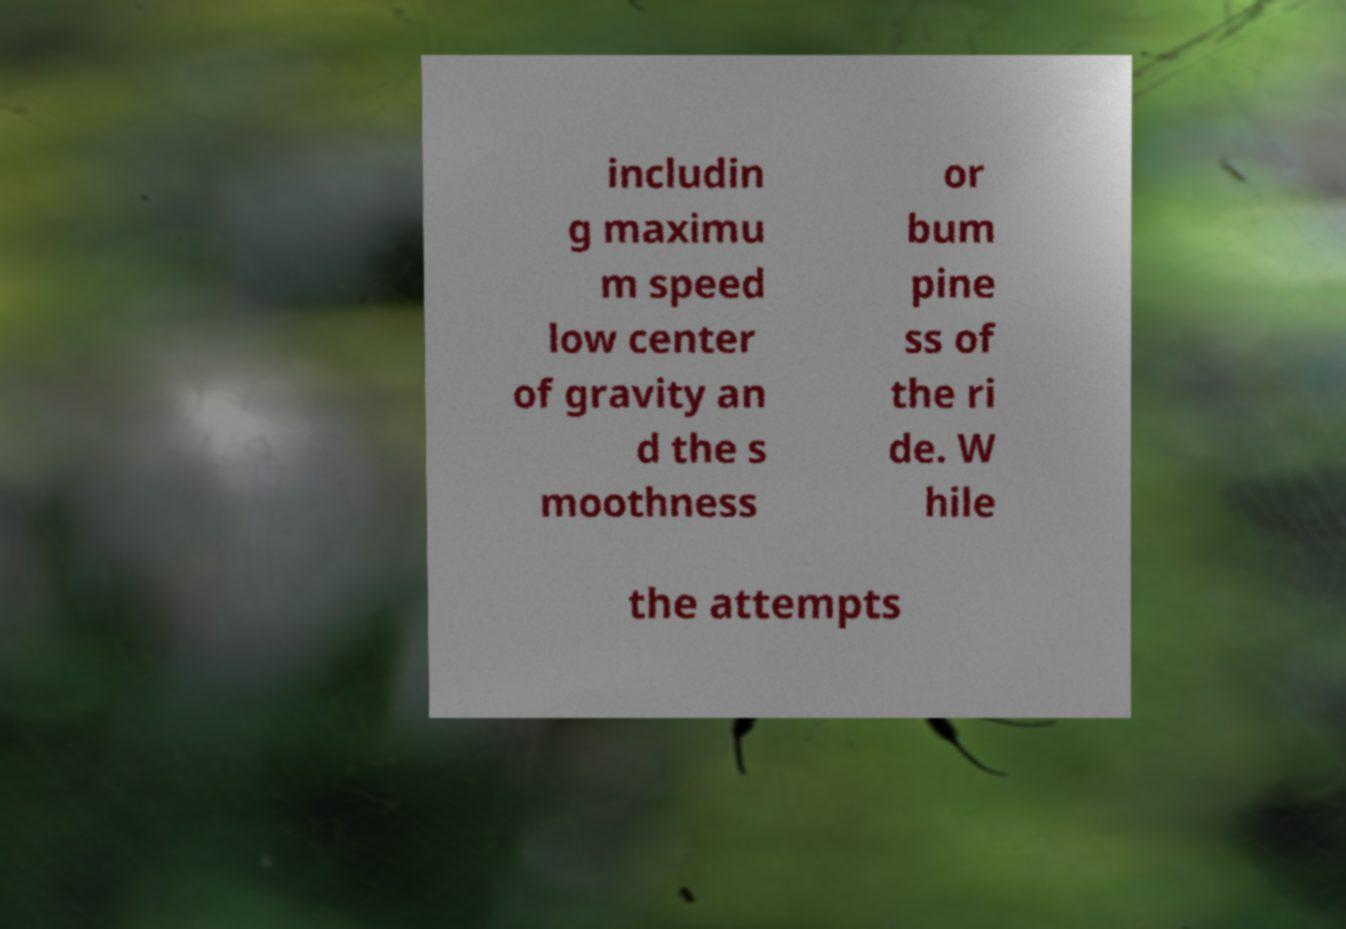There's text embedded in this image that I need extracted. Can you transcribe it verbatim? includin g maximu m speed low center of gravity an d the s moothness or bum pine ss of the ri de. W hile the attempts 